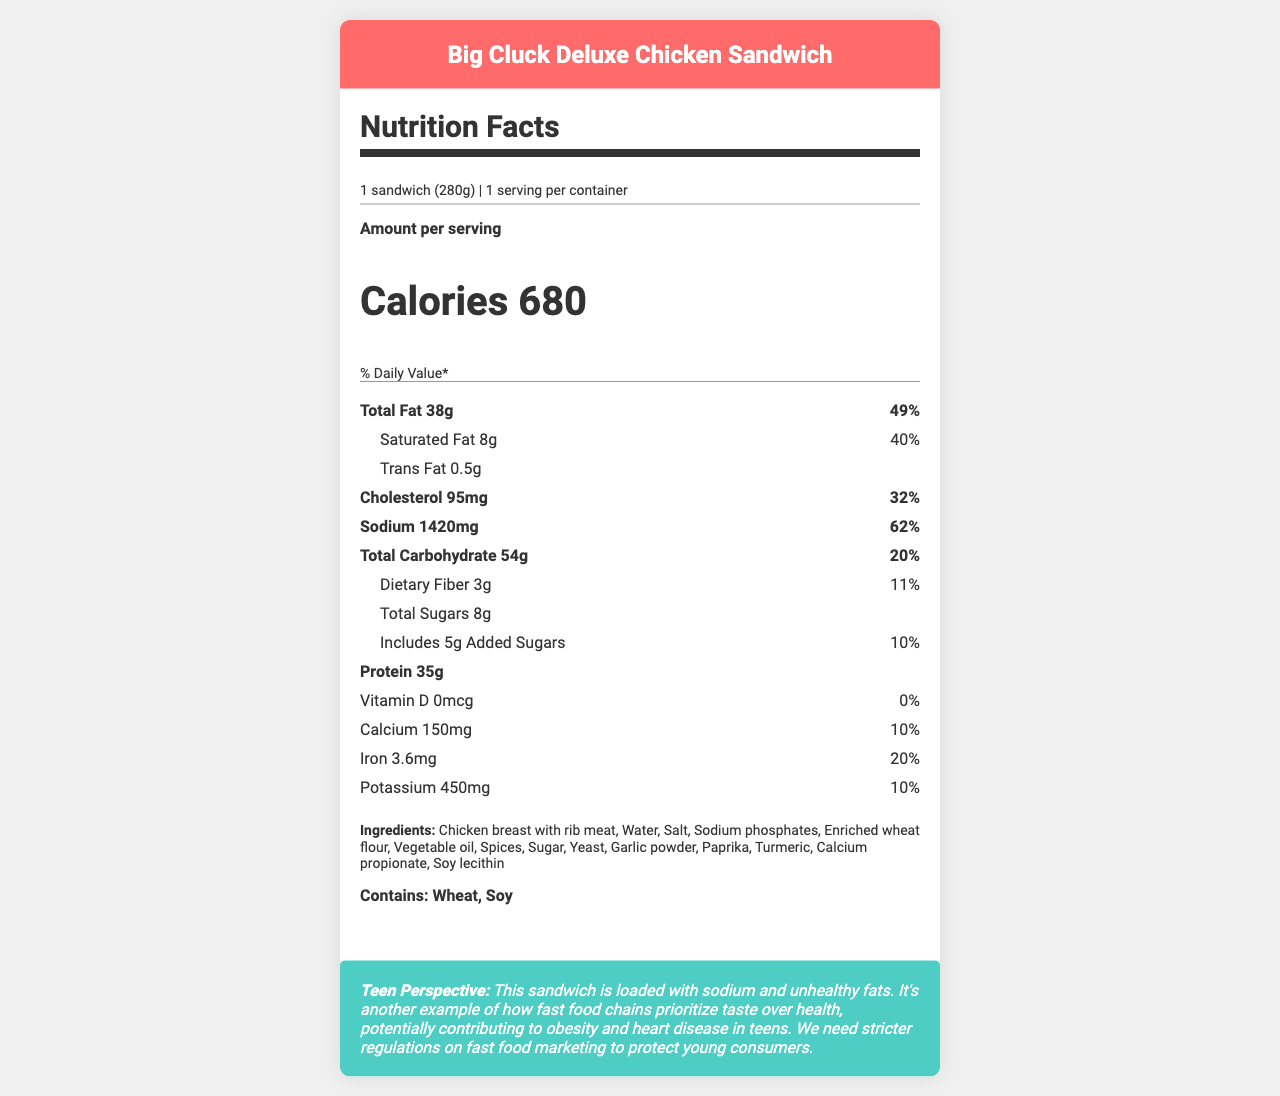how many calories does the Big Cluck Deluxe Chicken Sandwich have? The document explicitly states that the Big Cluck Deluxe Chicken Sandwich contains 680 calories.
Answer: 680 what is the serving size for the Big Cluck Deluxe Chicken Sandwich? The serving size is clearly mentioned as "1 sandwich (280g)".
Answer: 1 sandwich (280g) how much sodium does one serving of the sandwich contain? The sodium content for one serving of the sandwich is listed as 1420 mg.
Answer: 1420 mg what is the % Daily Value of saturated fat in the sandwich? The % Daily Value for saturated fat in the sandwich is 40%, which is given directly in the document.
Answer: 40% what are the allergens present in the Big Cluck Deluxe Chicken Sandwich? The document lists the allergens as "Contains: Wheat, Soy".
Answer: Wheat, Soy how much protein is in the Big Cluck Deluxe Chicken Sandwich? A. 25g B. 35g C. 45g D. 55g The nutrition facts state that the sandwich contains 35g of protein.
Answer: B. 35g what is the total fat content of the sandwich? A. 28g B. 38g C. 48g The document specifies that the total fat content is 38g.
Answer: B. 38g does the sandwich contain any Vitamin D? The document shows 0 mcg of Vitamin D, which indicates that the sandwich does not contain any Vitamin D.
Answer: No briefly summarize the overall nutritional profile of the sandwich. The summary includes the key nutritional aspects: high calories, fat, sodium, and notable protein content. It also acknowledges the presence of sugars and fiber.
Answer: The Big Cluck Deluxe Chicken Sandwich is high in calories (680), total fat (38g), saturated fat (8g), and sodium (1420mg). It has a considerable amount of protein (35g) and contains sugars, fiber, and various vitamins and minerals. how much potassium does the sandwich contain? The document lists that the sandwich contains 450 mg of potassium.
Answer: 450 mg why might the high sodium and saturated fat content be concerning? The document's analysis can point out that high sodium intake is linked to hypertension, and saturated fats are linked to heart disease, making these components concerning.
Answer: They can contribute to health issues like hypertension and heart disease. what is the slogan of the company that makes this sandwich? The slogan listed in the document is "Cluckin' Good!".
Answer: "Cluckin' Good!" does the document provide the recipe for the sandwich? The document lists ingredients but does not provide a step-by-step recipe.
Answer: Not enough information who is the target audience for the teen perspective provided? The teen perspective targets young consumers, advocating for stricter regulations on fast food marketing to protect them.
Answer: Young consumers which vitamin or mineral has the highest % Daily Value in this sandwich? A. Iron B. Calcium C. Potassium D. Vitamin D The % Daily Value for Iron is 20%, which is the highest among the listed options.
Answer: A. Iron can we determine the exact amount of turmeric in the sandwich from the document? The document lists turmeric as an ingredient but does not specify the exact amount.
Answer: No 